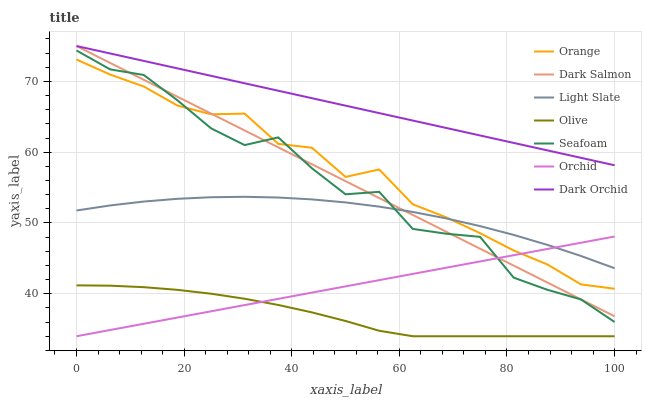Does Olive have the minimum area under the curve?
Answer yes or no. Yes. Does Dark Orchid have the maximum area under the curve?
Answer yes or no. Yes. Does Seafoam have the minimum area under the curve?
Answer yes or no. No. Does Seafoam have the maximum area under the curve?
Answer yes or no. No. Is Dark Salmon the smoothest?
Answer yes or no. Yes. Is Seafoam the roughest?
Answer yes or no. Yes. Is Dark Orchid the smoothest?
Answer yes or no. No. Is Dark Orchid the roughest?
Answer yes or no. No. Does Olive have the lowest value?
Answer yes or no. Yes. Does Seafoam have the lowest value?
Answer yes or no. No. Does Dark Salmon have the highest value?
Answer yes or no. Yes. Does Seafoam have the highest value?
Answer yes or no. No. Is Olive less than Dark Salmon?
Answer yes or no. Yes. Is Dark Orchid greater than Orchid?
Answer yes or no. Yes. Does Light Slate intersect Orange?
Answer yes or no. Yes. Is Light Slate less than Orange?
Answer yes or no. No. Is Light Slate greater than Orange?
Answer yes or no. No. Does Olive intersect Dark Salmon?
Answer yes or no. No. 